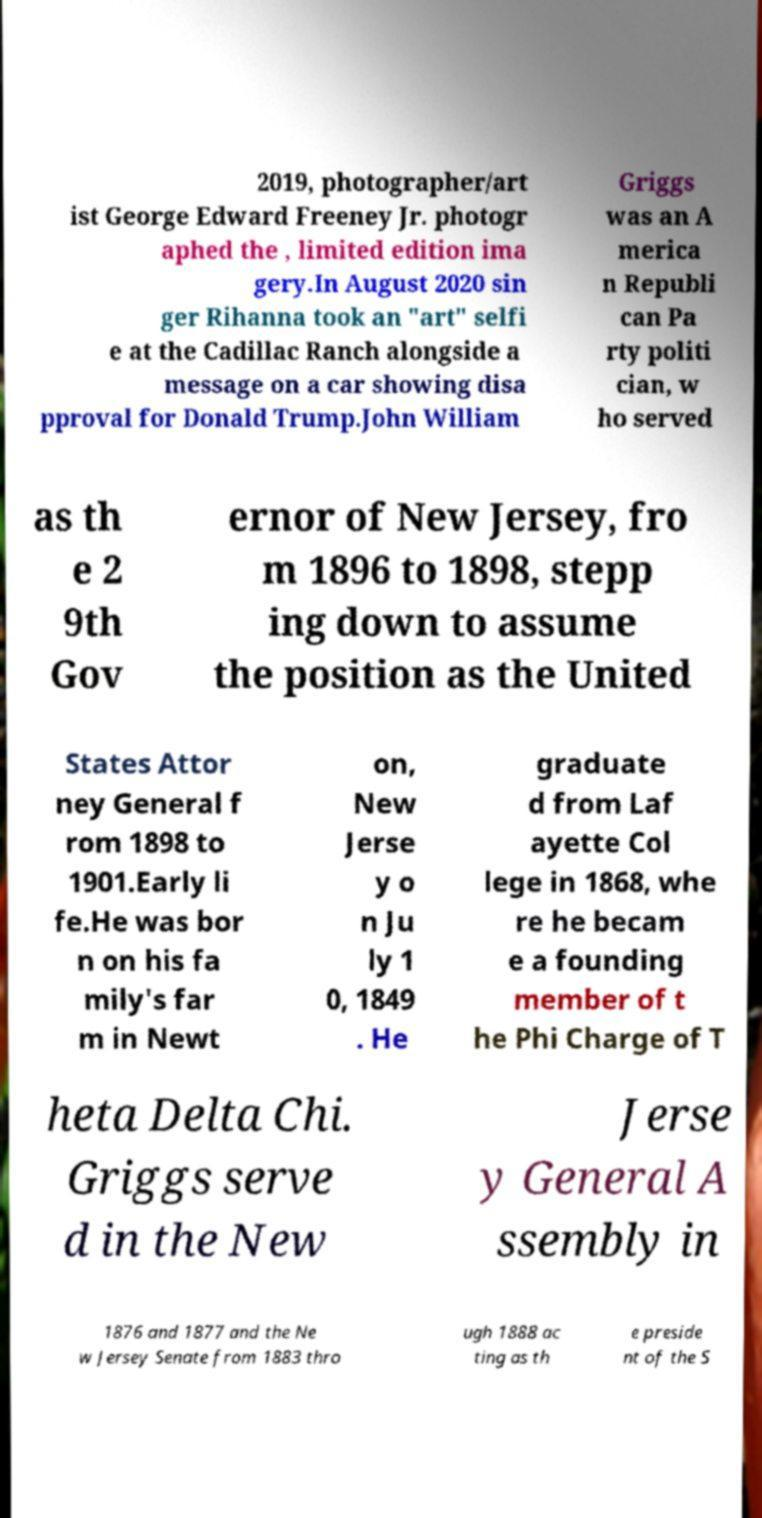I need the written content from this picture converted into text. Can you do that? 2019, photographer/art ist George Edward Freeney Jr. photogr aphed the , limited edition ima gery.In August 2020 sin ger Rihanna took an "art" selfi e at the Cadillac Ranch alongside a message on a car showing disa pproval for Donald Trump.John William Griggs was an A merica n Republi can Pa rty politi cian, w ho served as th e 2 9th Gov ernor of New Jersey, fro m 1896 to 1898, stepp ing down to assume the position as the United States Attor ney General f rom 1898 to 1901.Early li fe.He was bor n on his fa mily's far m in Newt on, New Jerse y o n Ju ly 1 0, 1849 . He graduate d from Laf ayette Col lege in 1868, whe re he becam e a founding member of t he Phi Charge of T heta Delta Chi. Griggs serve d in the New Jerse y General A ssembly in 1876 and 1877 and the Ne w Jersey Senate from 1883 thro ugh 1888 ac ting as th e preside nt of the S 